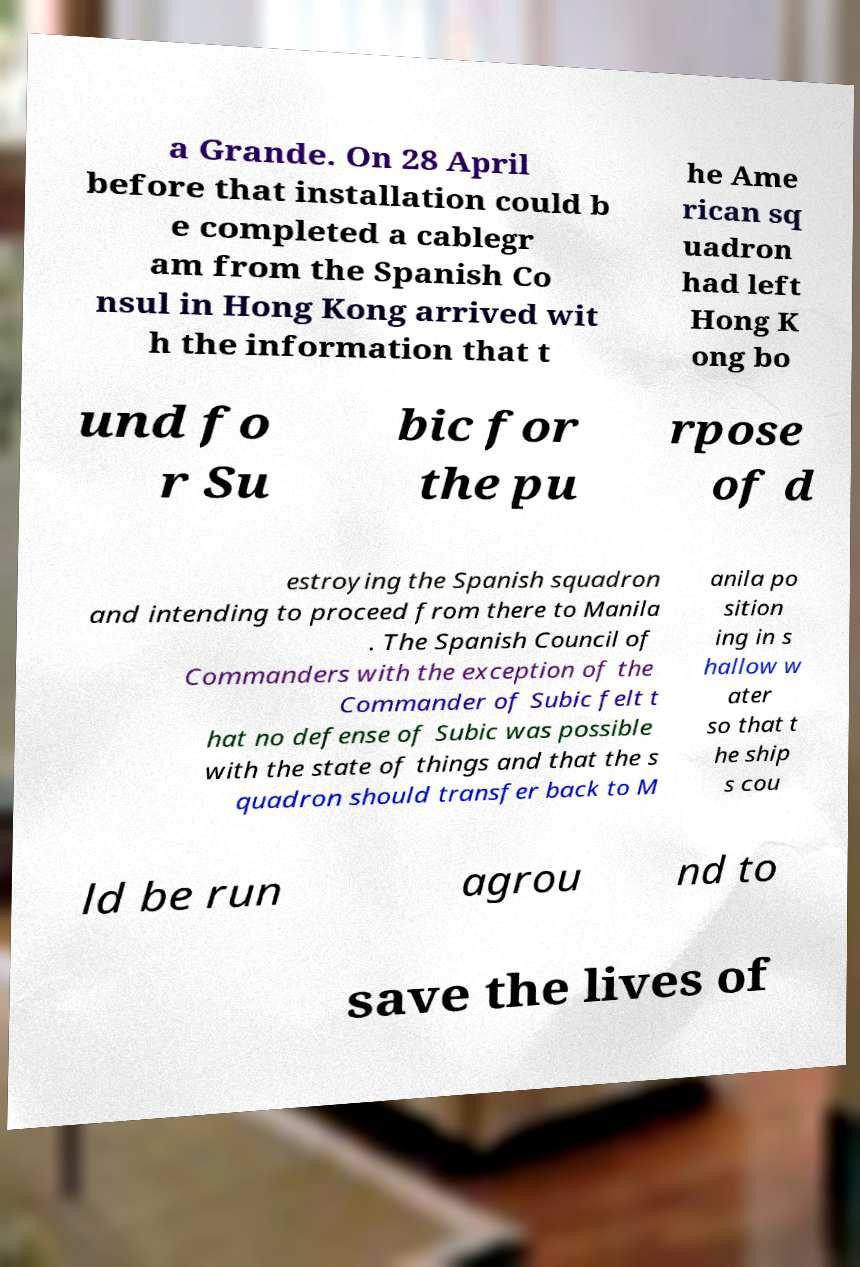Can you accurately transcribe the text from the provided image for me? a Grande. On 28 April before that installation could b e completed a cablegr am from the Spanish Co nsul in Hong Kong arrived wit h the information that t he Ame rican sq uadron had left Hong K ong bo und fo r Su bic for the pu rpose of d estroying the Spanish squadron and intending to proceed from there to Manila . The Spanish Council of Commanders with the exception of the Commander of Subic felt t hat no defense of Subic was possible with the state of things and that the s quadron should transfer back to M anila po sition ing in s hallow w ater so that t he ship s cou ld be run agrou nd to save the lives of 